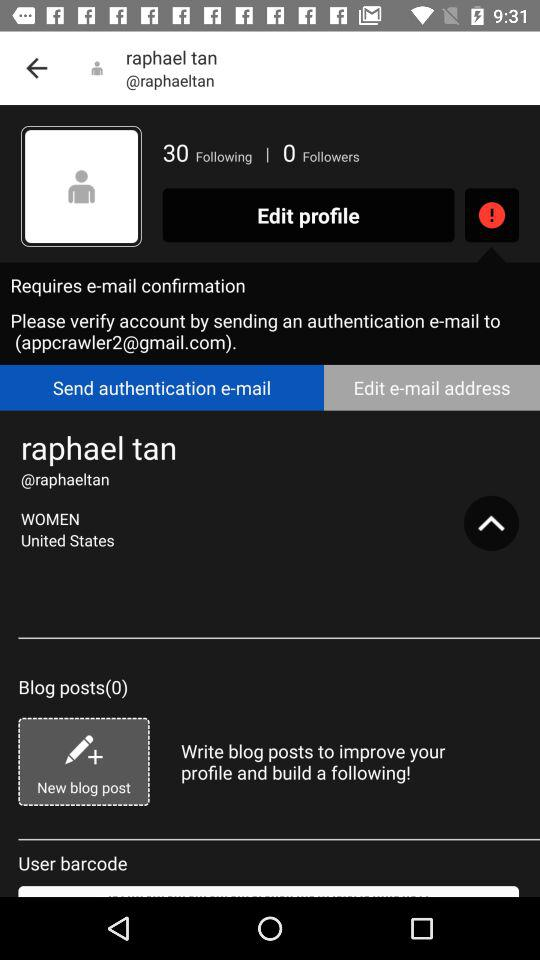What is the gender? The gender is women. 